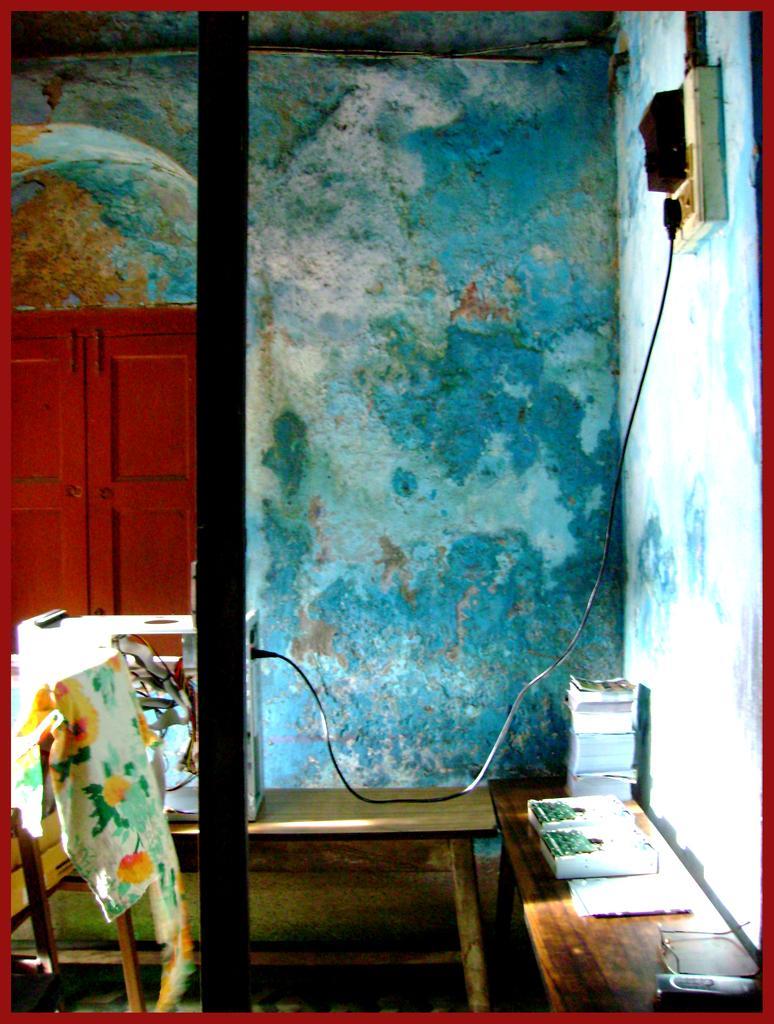How would you summarize this image in a sentence or two? In this image we can see the wall. And we can see the switch board. And we can see the cables. And we can see the spectacles, books and some other objects on the wooden table. 